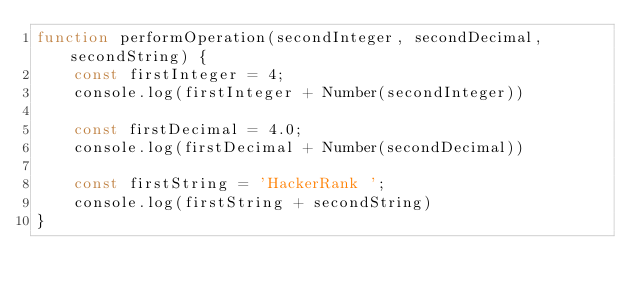Convert code to text. <code><loc_0><loc_0><loc_500><loc_500><_JavaScript_>function performOperation(secondInteger, secondDecimal, secondString) {
    const firstInteger = 4;
    console.log(firstInteger + Number(secondInteger))

    const firstDecimal = 4.0;
    console.log(firstDecimal + Number(secondDecimal))
    
    const firstString = 'HackerRank ';
    console.log(firstString + secondString)
}</code> 